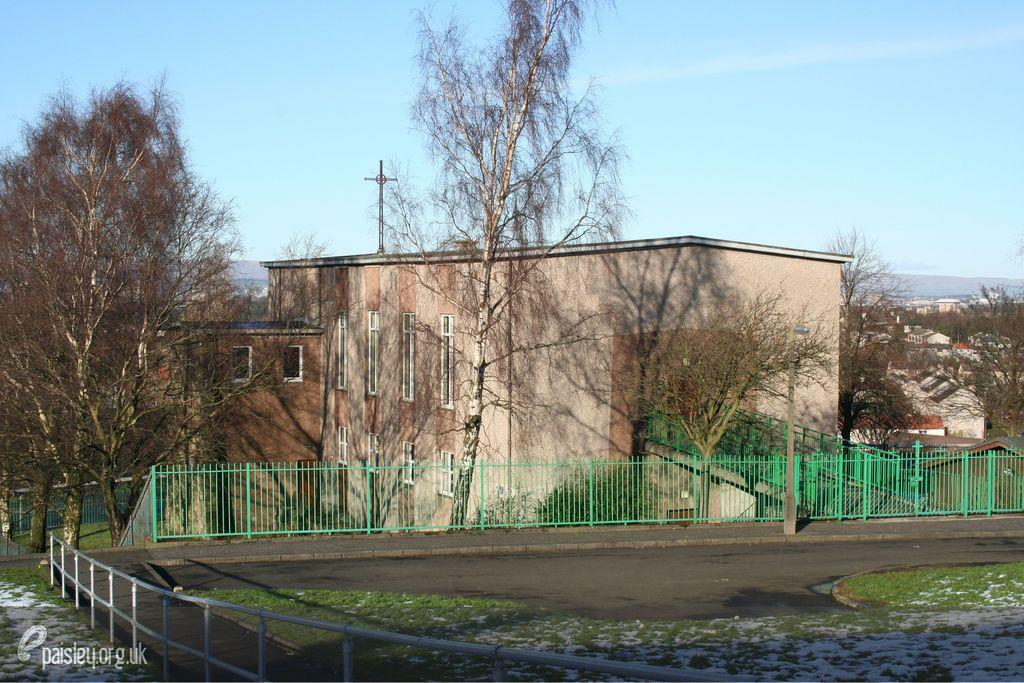What type of structures can be seen in the image? There are buildings in the image. What feature can be observed on the buildings? There are windows visible in the image. What type of vegetation is present in the image? There are trees in the image. What type of barrier is present in the image? There is fencing in the image. What part of the natural environment is visible in the image? The sky is visible in the image. What type of ground cover is present in the image? There is grass in the image. How many books are stacked on the heart in the image? There are no books or hearts present in the image. 